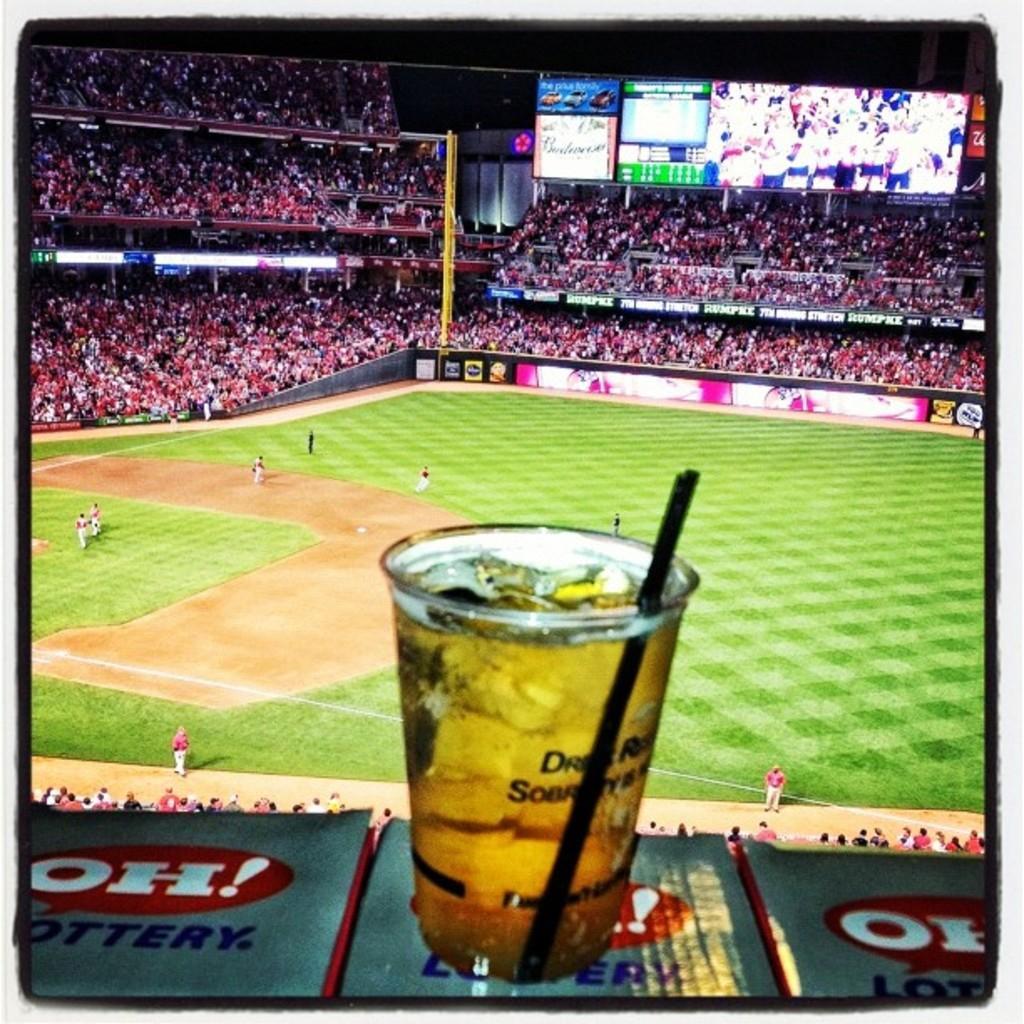Describe this image in one or two sentences. In the middle of the image there is a glass with ice cubes, black straw and a liquid in it. Behind the glass there is a ground with few people. And in the background there is crowd in the stadium. And also there is a screen. 